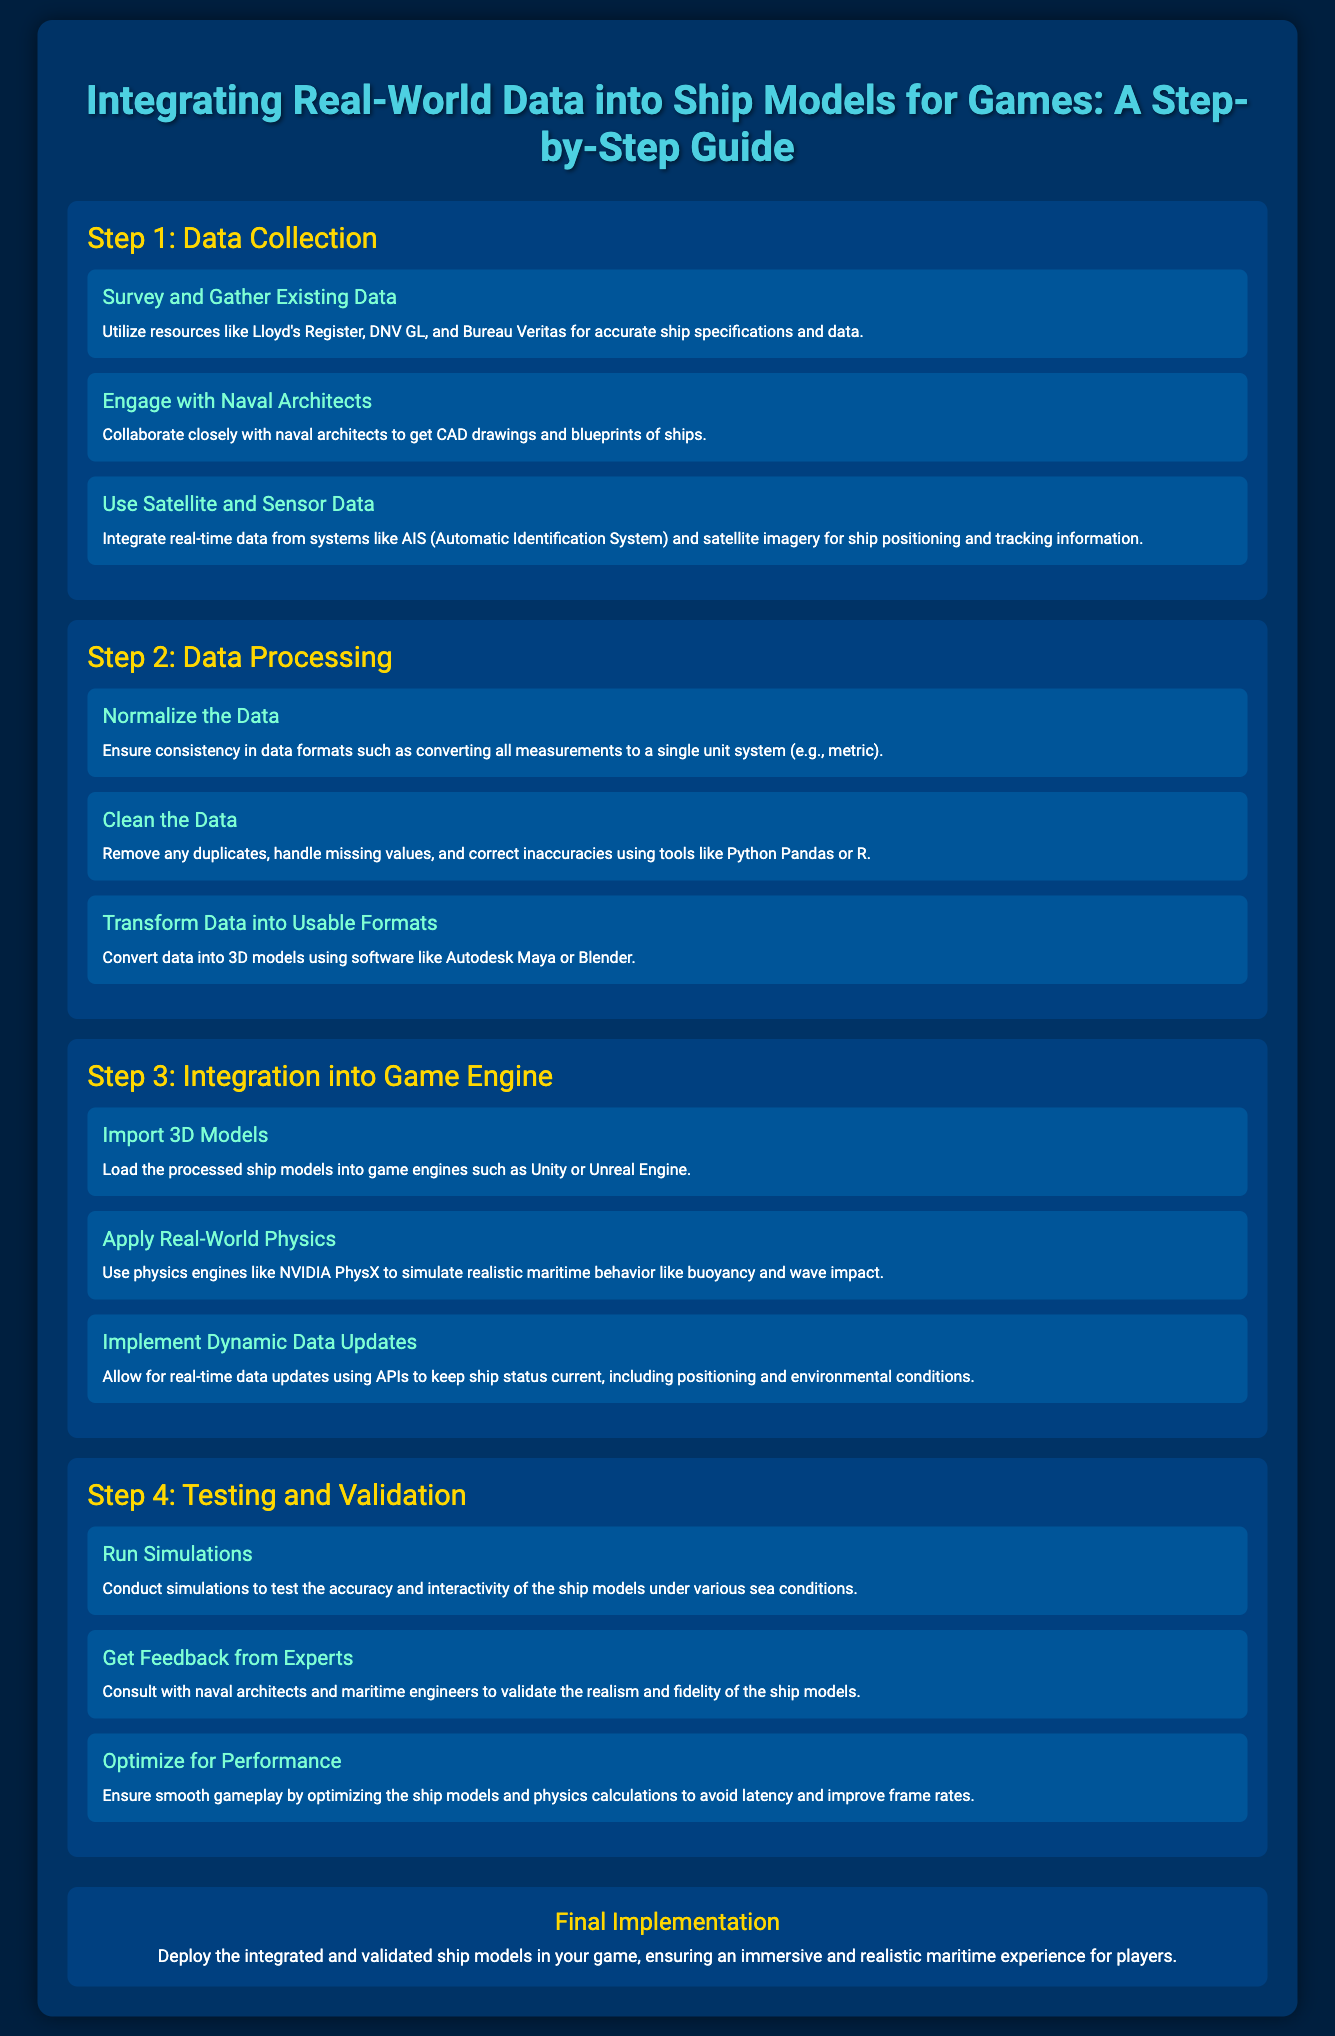what is the title of the document? The title is presented in the header of the document, which states the subject matter clearly.
Answer: Integrating Real-World Data into Ship Models for Games: A Step-by-Step Guide how many steps are there in the guide? The document outlines a specific number of steps to follow for integration, clearly listed.
Answer: 4 what is the first element under Step 1? The first element listed in Step 1 provides an initial action to take and is mentioned specifically.
Answer: Survey and Gather Existing Data which software is suggested for transforming data into usable formats? A specific software is recommended for the transformation of data mentioned in the processing step.
Answer: Autodesk Maya or Blender what type of engineers should provide feedback during the testing phase? The document specifies a type of expert that should be consulted for validation in the testing section.
Answer: Maritime engineers which physics engine is mentioned for applying real-world physics? The document specifically names a physics engine that can be utilized in the integration of ship models.
Answer: NVIDIA PhysX what is the focus of the final implementation? The footer of the document summarizes the key goal to be achieved after following the steps outlined in the guide.
Answer: Immersive and realistic maritime experience how many elements are listed under Step 3? The number of elements described in Step 3 provides insight into the integration process.
Answer: 3 